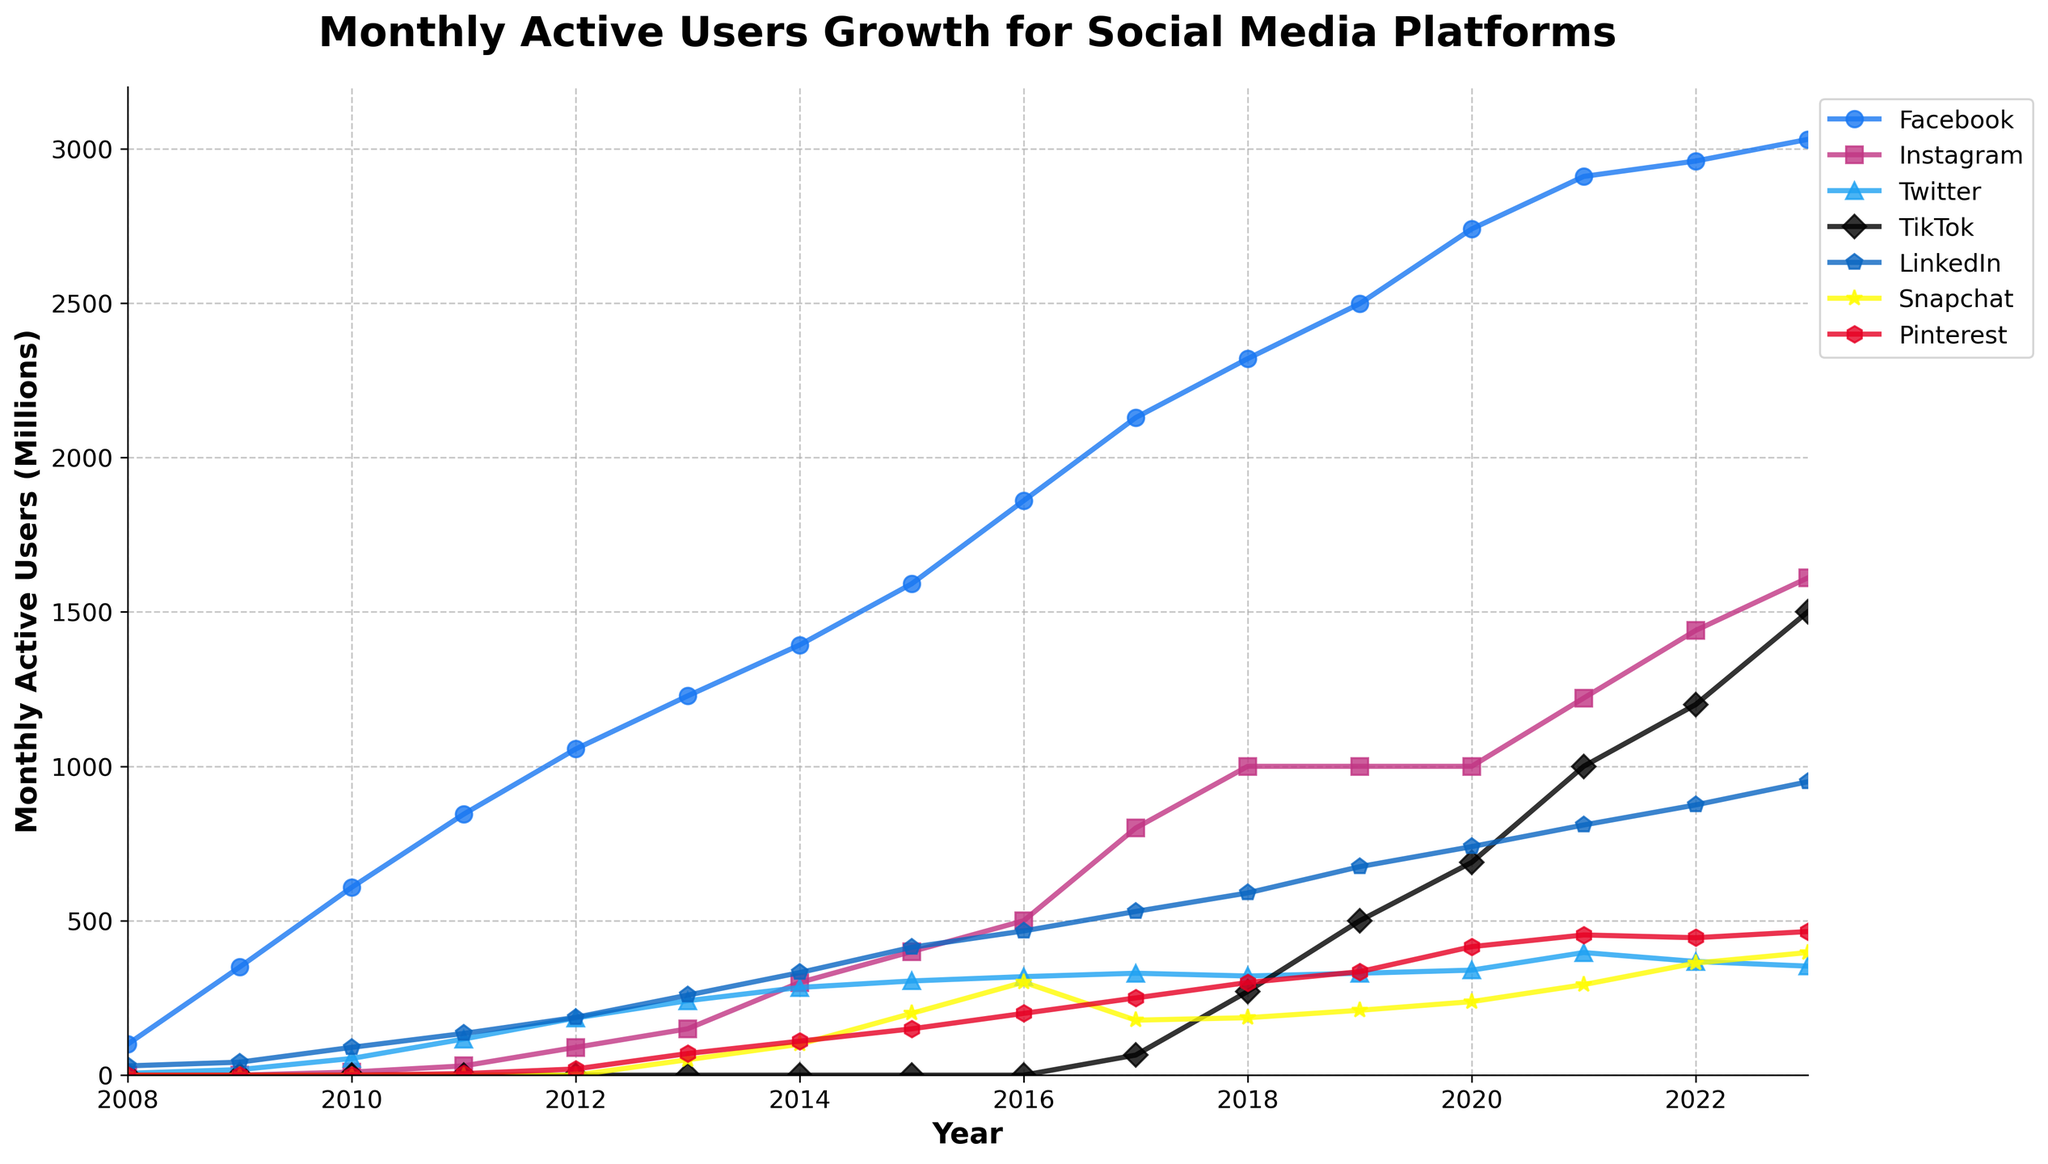What's the highest number of monthly active users Facebook reached in the period shown? By referring to the Facebook line on the plot, identify the peak value. The highest point in 2023 shows Facebook with 3030 million users.
Answer: 3030 Which social media platform saw the fastest rise in users between 2017 and 2021? Compare the slopes of the different lines between 2017 and 2021. TikTok's line has the steepest slope, indicating the fastest growth in users during this period.
Answer: TikTok Which year did Instagram first surpass 1000 million monthly active users? Locate the point where Instagram's line crosses the 1000 million users mark. Instagram first reached 1000 million users in 2018.
Answer: 2018 How many more monthly active users did LinkedIn have in 2023 compared to 2008? Subtract the number of users in 2008 from the number in 2023 for LinkedIn. In 2023, LinkedIn had 950 million users and in 2008, it had 30 million users, so 950 - 30 = 920 million.
Answer: 920 Which two platforms had the closest number of users in 2020, and what were their user numbers? Compare the user numbers for all platforms in 2020. Snapchat and Pinterest had very close numbers with 238 million and 416 million respectively.
Answer: Snapchat (238), Pinterest (416) What is the average annual growth of monthly active users for Facebook from 2008 to 2023? First, find the total growth: 3030 million in 2023 minus 100 million in 2008, which is 3030 - 100 = 2930 million. Then, divide by the number of years (2023 - 2008 = 15). So, 2930 / 15 = 195.33 million.
Answer: 195.33 million Did Pinterest ever surpass Snapchat in monthly active users between 2008 and 2023? Check the relative positions of Pinterest and Snapchat lines over the years. Pinterest never surpasses Snapchat in users at any point in the period shown.
Answer: No Which platform had the least fluctuation in its user growth trend? Look for the platform with the smoothest line indicating steady growth without sharp changes. LinkedIn and Facebook have relatively steady growth, but LinkedIn seems the smoothest.
Answer: LinkedIn In which year did TikTok reach 1000 million monthly active users? Locate the point where TikTok's line crosses the 1000 million mark. TikTok reached 1000 million users in 2021.
Answer: 2021 